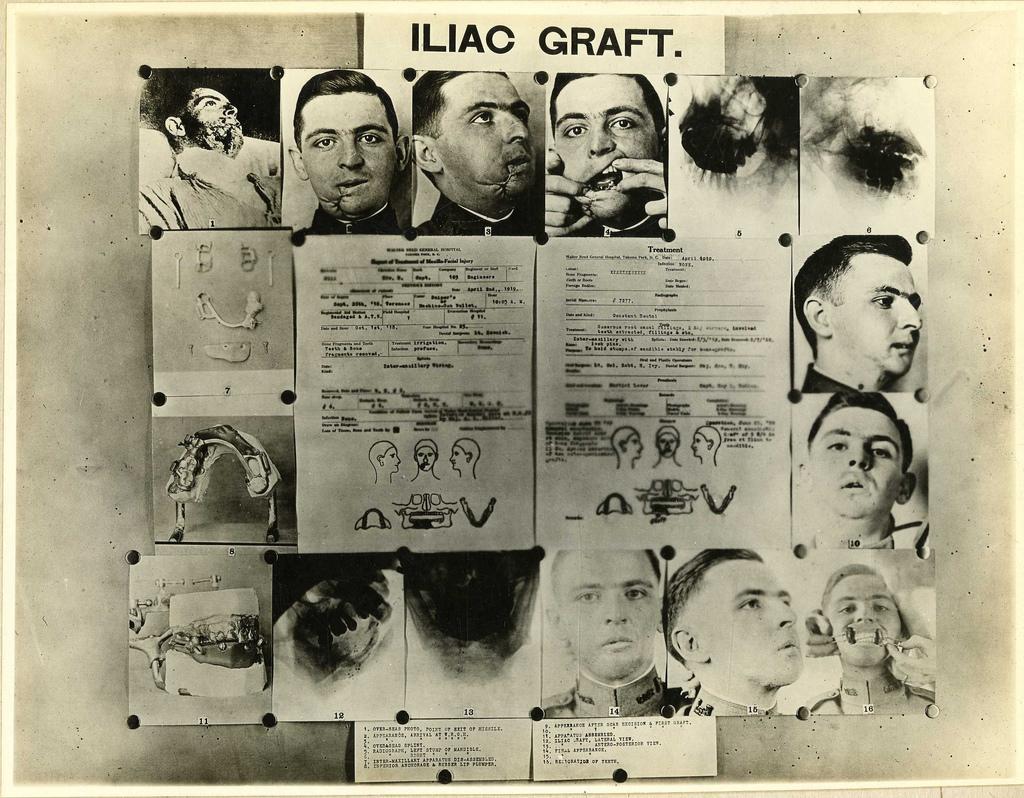Describe this image in one or two sentences. In this image at the center there are many pictures of the persons. 